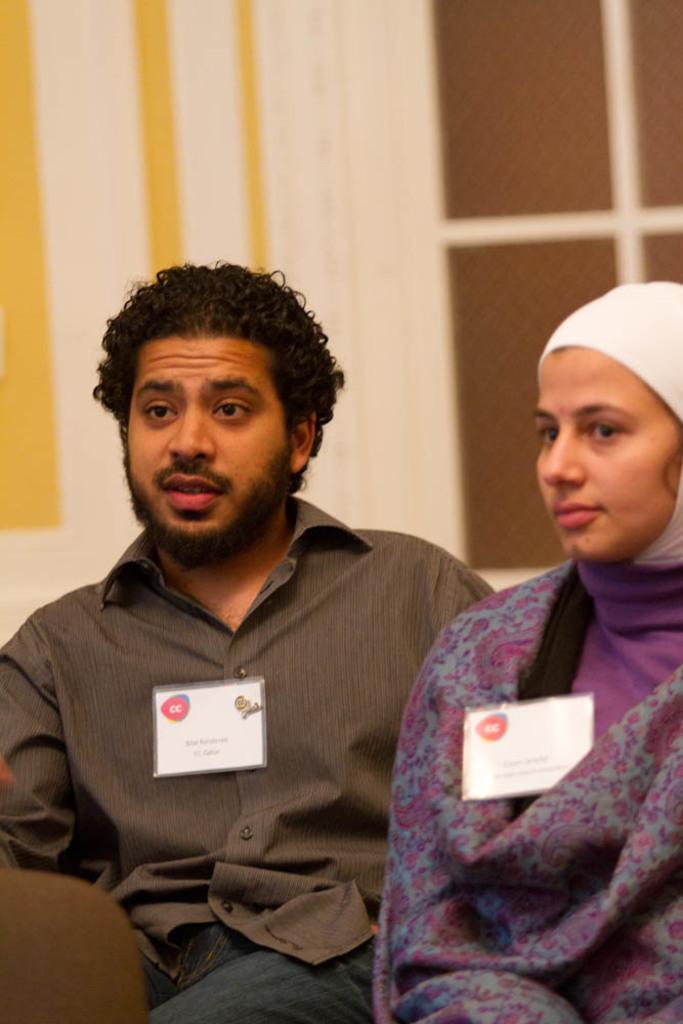Please provide a concise description of this image. In this picture we can see a man and a woman are sitting, we can also see two cards, in the background it looks like a wall. 